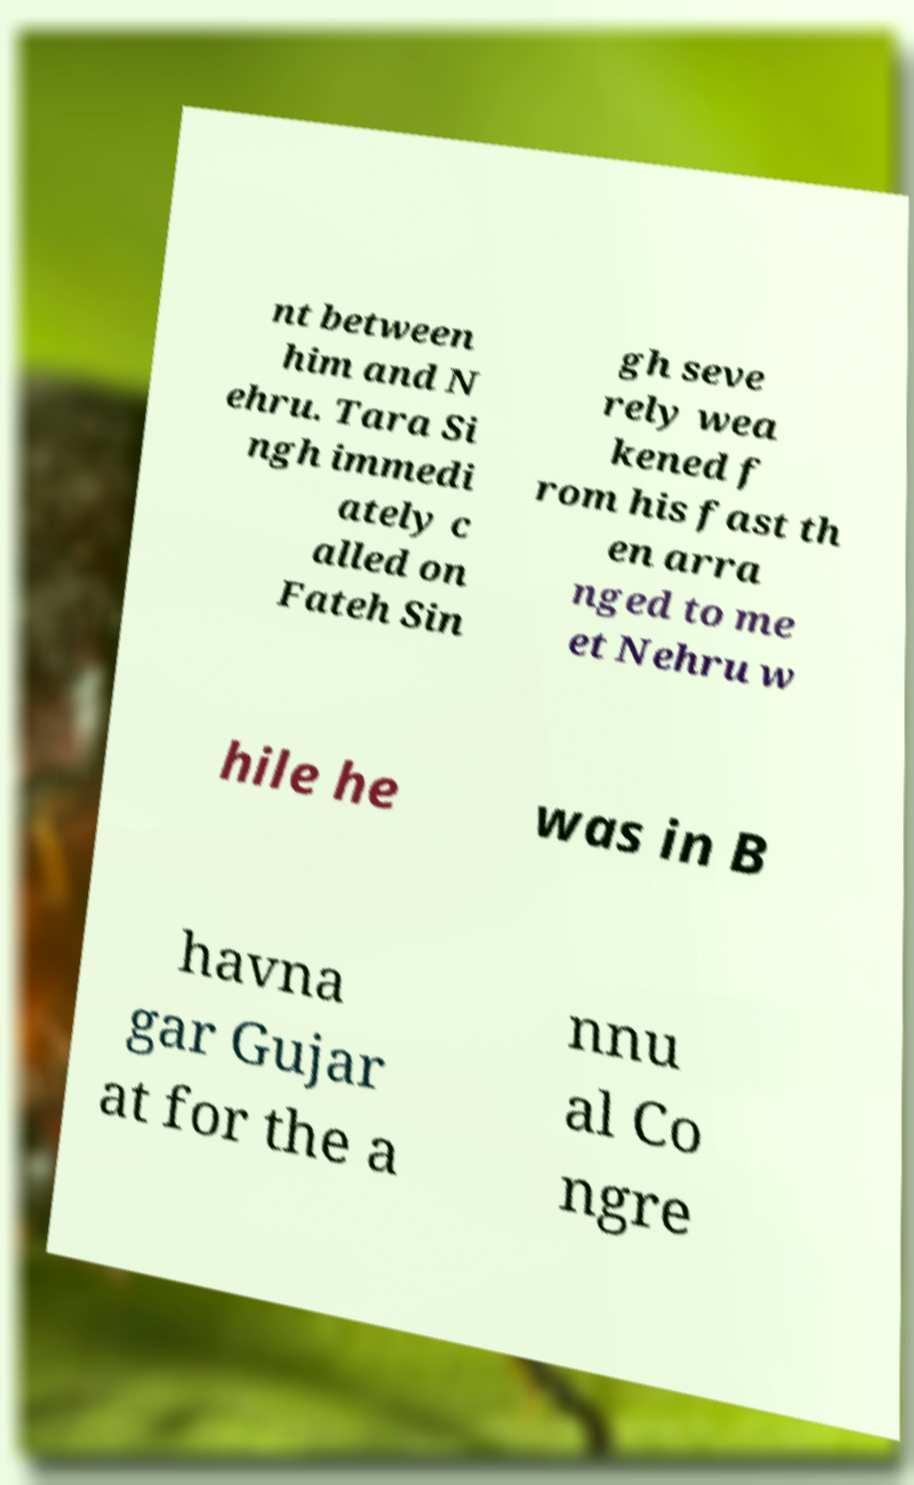Can you read and provide the text displayed in the image?This photo seems to have some interesting text. Can you extract and type it out for me? nt between him and N ehru. Tara Si ngh immedi ately c alled on Fateh Sin gh seve rely wea kened f rom his fast th en arra nged to me et Nehru w hile he was in B havna gar Gujar at for the a nnu al Co ngre 